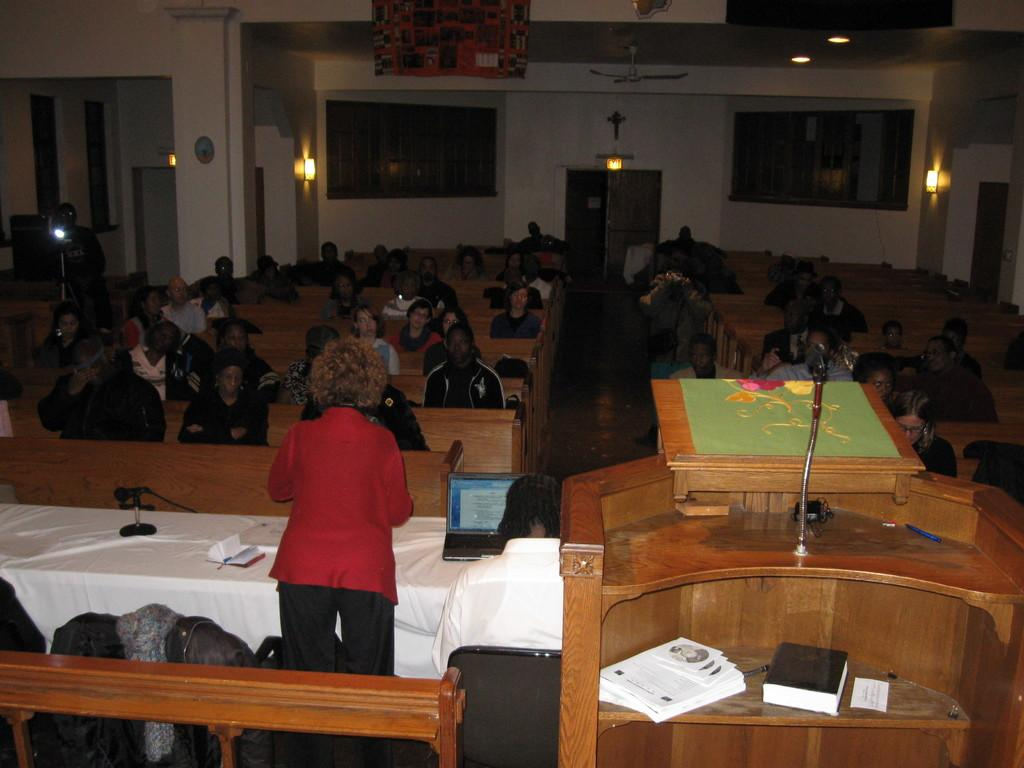What type of setting is shown in the image? The image depicts a meeting room. What are the people in the room doing? People are seated in the room. Can you describe the woman in the image? There is a woman standing and speaking in the image. What is the woman using to amplify her voice? A podium with a microphone is present in the image. Are there any objects related to learning or knowledge in the image? Yes, there are books visible in the image. What type of soup is being served in the image? There is no soup present in the image; it depicts a meeting room with people seated and a woman speaking. 